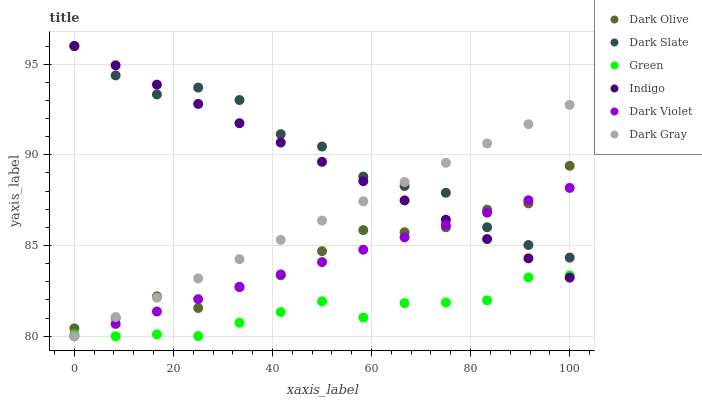Does Green have the minimum area under the curve?
Answer yes or no. Yes. Does Dark Slate have the maximum area under the curve?
Answer yes or no. Yes. Does Dark Olive have the minimum area under the curve?
Answer yes or no. No. Does Dark Olive have the maximum area under the curve?
Answer yes or no. No. Is Dark Gray the smoothest?
Answer yes or no. Yes. Is Dark Slate the roughest?
Answer yes or no. Yes. Is Dark Olive the smoothest?
Answer yes or no. No. Is Dark Olive the roughest?
Answer yes or no. No. Does Dark Violet have the lowest value?
Answer yes or no. Yes. Does Dark Olive have the lowest value?
Answer yes or no. No. Does Dark Slate have the highest value?
Answer yes or no. Yes. Does Dark Olive have the highest value?
Answer yes or no. No. Is Green less than Dark Olive?
Answer yes or no. Yes. Is Dark Olive greater than Green?
Answer yes or no. Yes. Does Dark Olive intersect Dark Gray?
Answer yes or no. Yes. Is Dark Olive less than Dark Gray?
Answer yes or no. No. Is Dark Olive greater than Dark Gray?
Answer yes or no. No. Does Green intersect Dark Olive?
Answer yes or no. No. 